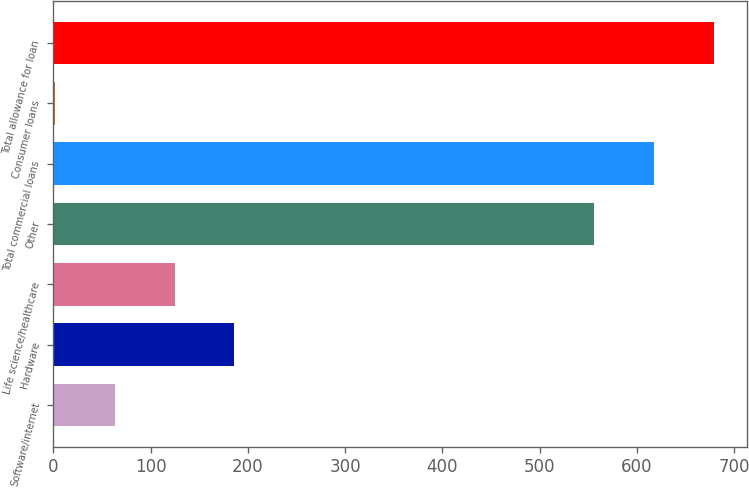Convert chart to OTSL. <chart><loc_0><loc_0><loc_500><loc_500><bar_chart><fcel>Software/internet<fcel>Hardware<fcel>Life science/healthcare<fcel>Other<fcel>Total commercial loans<fcel>Consumer loans<fcel>Total allowance for loan<nl><fcel>63.4<fcel>186.2<fcel>124.8<fcel>556<fcel>617.4<fcel>2<fcel>678.8<nl></chart> 